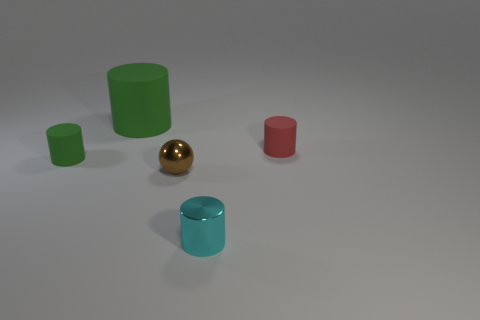Add 1 tiny gray metal cubes. How many objects exist? 6 Subtract all big cylinders. How many cylinders are left? 3 Subtract all green cylinders. How many cylinders are left? 2 Subtract 1 cylinders. How many cylinders are left? 3 Subtract all blue cylinders. Subtract all brown balls. How many cylinders are left? 4 Subtract all purple spheres. How many brown cylinders are left? 0 Subtract all small red rubber cubes. Subtract all red matte things. How many objects are left? 4 Add 1 tiny rubber things. How many tiny rubber things are left? 3 Add 4 red rubber cylinders. How many red rubber cylinders exist? 5 Subtract 0 yellow cylinders. How many objects are left? 5 